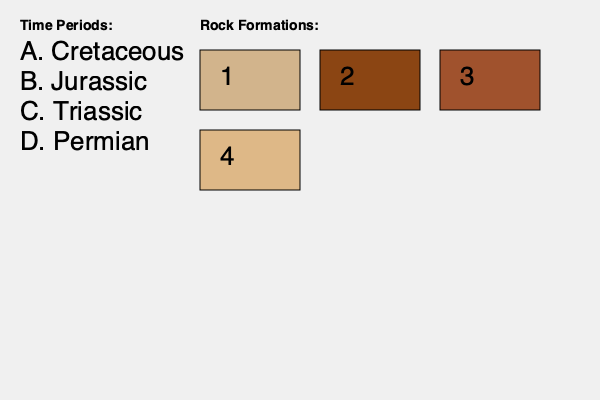Match the rock formations (1-4) with their corresponding geological time periods (A-D) based on their characteristics and typical fossils found in each formation. To match the rock formations with their corresponding geological time periods, we need to analyze the characteristics of each formation and consider the typical fossils found in each period:

1. Formation 1 (light tan): This color and texture suggest a sandstone formation, which is common in the Cretaceous period. The Cretaceous is known for its diverse dinosaur fossils and marine reptiles.

2. Formation 2 (dark brown): This color indicates a more compact, possibly metamorphic rock, which is typical of the Jurassic period. The Jurassic is famous for large dinosaurs like Stegosaurus and Allosaurus.

3. Formation 3 (reddish-brown): This coloration is often associated with iron-rich sedimentary rocks found in the Triassic period. The Triassic marks the beginning of dinosaur evolution and is known for early dinosaur fossils.

4. Formation 4 (light brown): This lighter coloration suggests limestone or dolomite, which are common in the Permian period. The Permian is known for its diverse marine fossils and early reptiles.

Matching the formations to the time periods:
1 - A (Cretaceous)
2 - B (Jurassic)
3 - C (Triassic)
4 - D (Permian)
Answer: 1-A, 2-B, 3-C, 4-D 